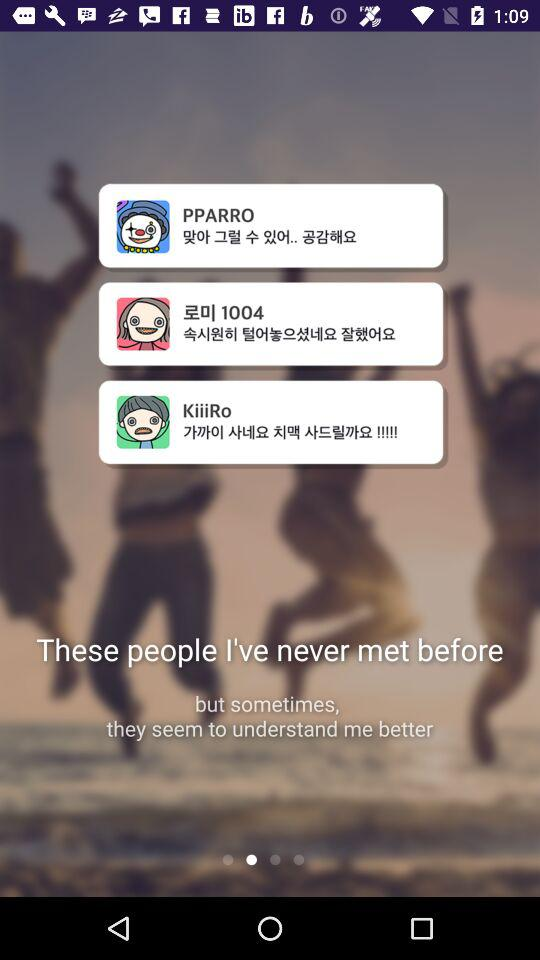How many people are on this page?
Answer the question using a single word or phrase. 3 